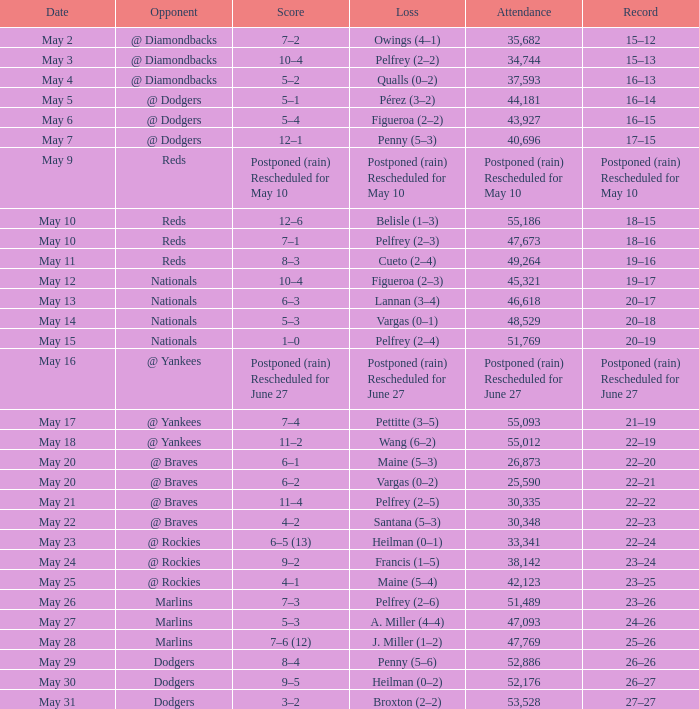Record of 19–16 occurred on what date? May 11. 